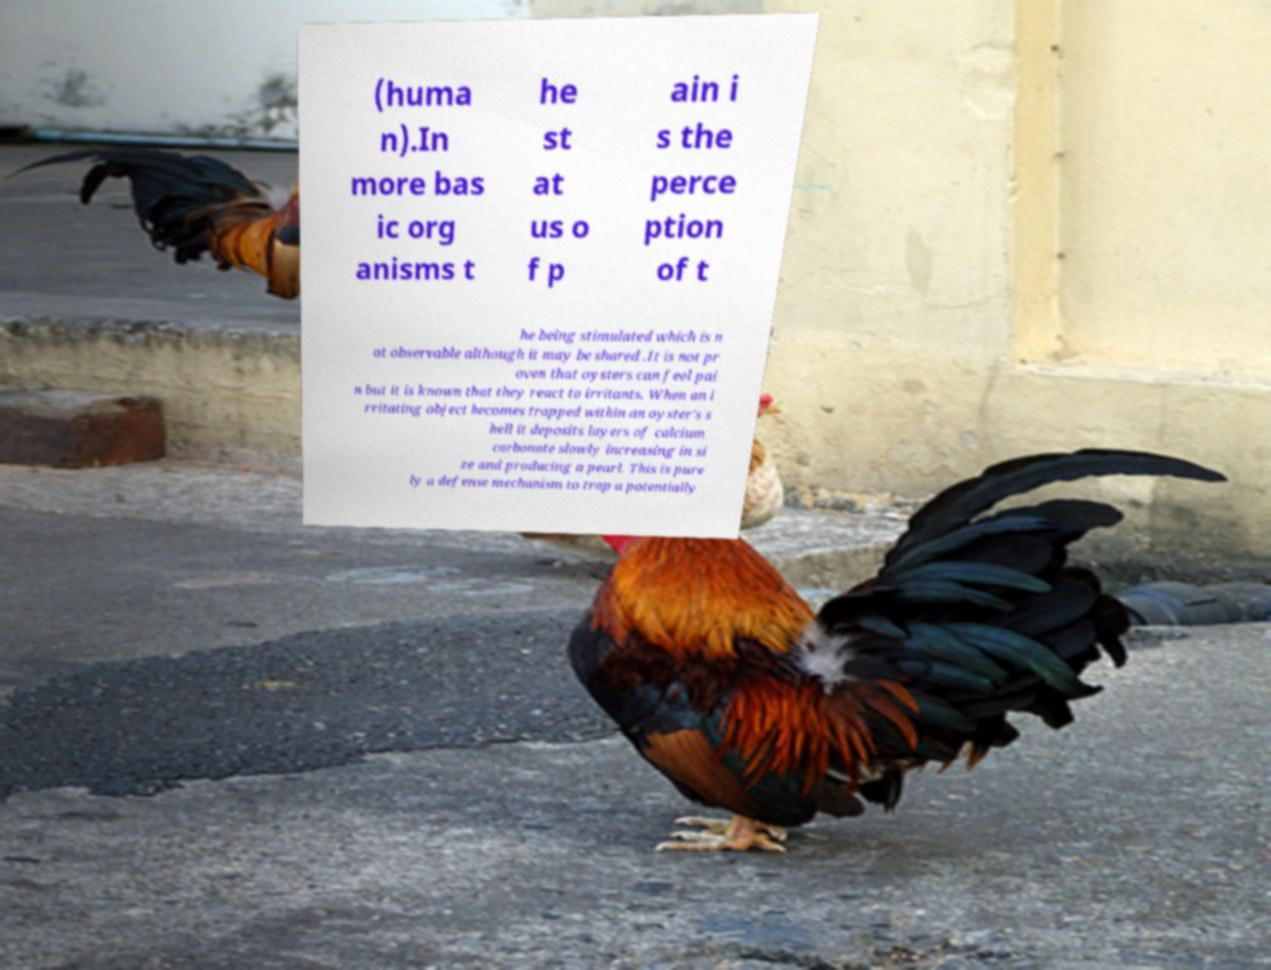Please identify and transcribe the text found in this image. (huma n).In more bas ic org anisms t he st at us o f p ain i s the perce ption of t he being stimulated which is n ot observable although it may be shared .It is not pr oven that oysters can feel pai n but it is known that they react to irritants. When an i rritating object becomes trapped within an oyster's s hell it deposits layers of calcium carbonate slowly increasing in si ze and producing a pearl. This is pure ly a defense mechanism to trap a potentially 